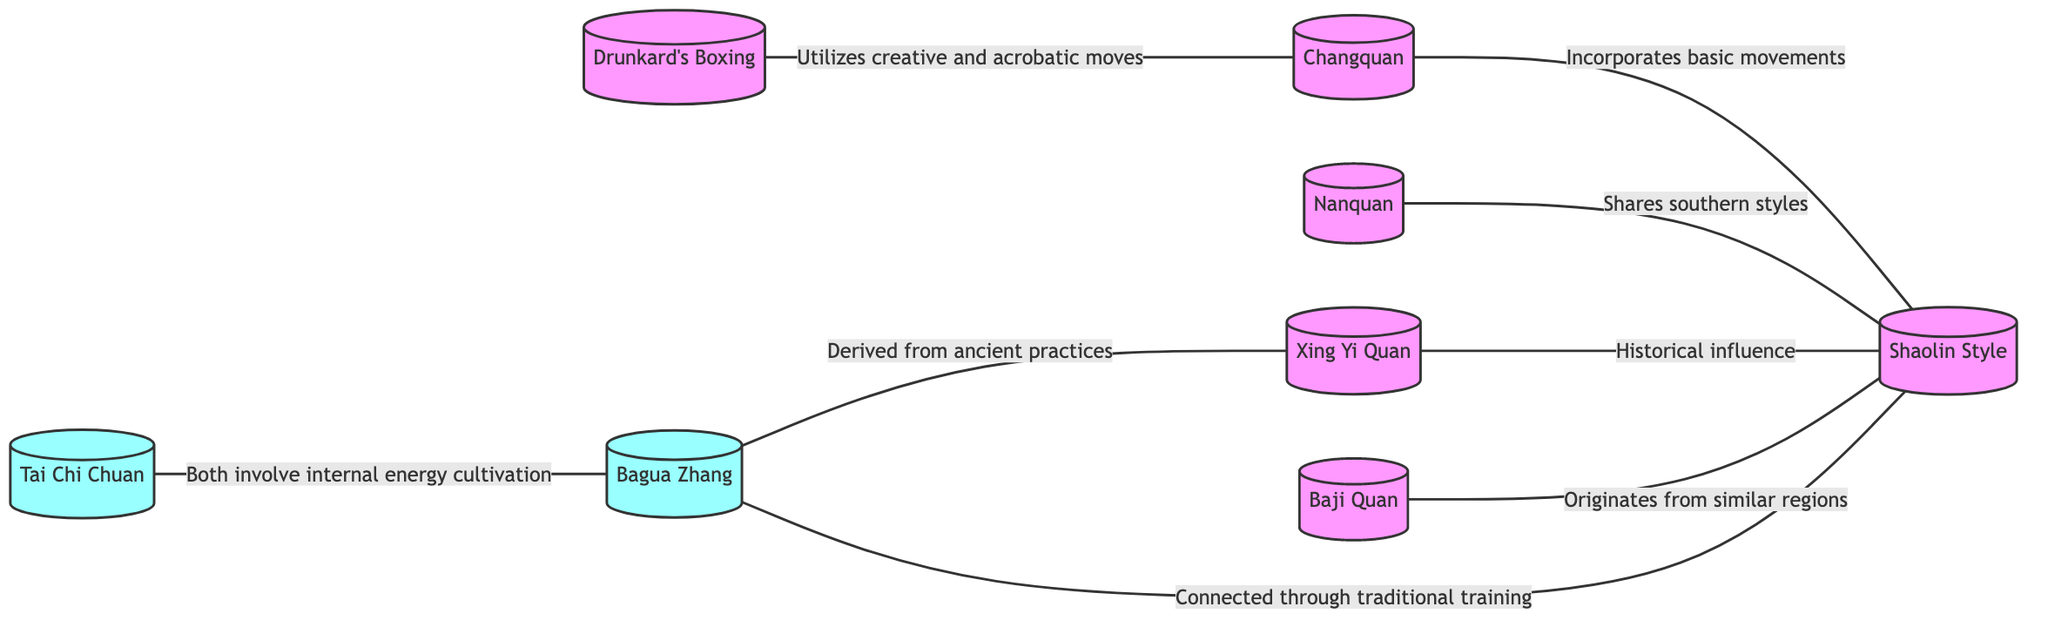What are the total number of nodes in the diagram? By counting the nodes listed in the diagram, there are 8 distinct techniques/styles: Changquan, Nanquan, Tai Chi Chuan, Bagua Zhang, Xing Yi Quan, Drunkard's Boxing, Shaolin Style, and Baji Quan.
Answer: 8 Which two styles are connected because they both involve internal energy cultivation? The connection is indicated between Tai Chi Chuan and Bagua Zhang, where the edge label specifically states that both involve internal energy cultivation.
Answer: Tai Chi Chuan, Bagua Zhang How many edges connect to the Shaolin Style? By examining the edges in the diagram, Shaolin Style is connected to four styles: Changquan, Nanquan, Xing Yi Quan, and Baji Quan. Therefore, there are four edges connected to Shaolin Style.
Answer: 4 Which style utilizes creative and acrobatic moves? The diagram specifies that Drunkard's Boxing utilizes creative and acrobatic moves, connecting it to Changquan.
Answer: Drunkard's Boxing What style shares southern styles with Nanquan? The edge indicates that Nanquan shares southern styles with Shaolin Style, establishing a direct relationship between the two.
Answer: Shaolin Style What is the relationship between Bagua Zhang and Xing Yi Quan? The diagram indicates that Bagua Zhang is derived from ancient practices, which is a direct connection to Xing Yi Quan.
Answer: Derived from ancient practices 